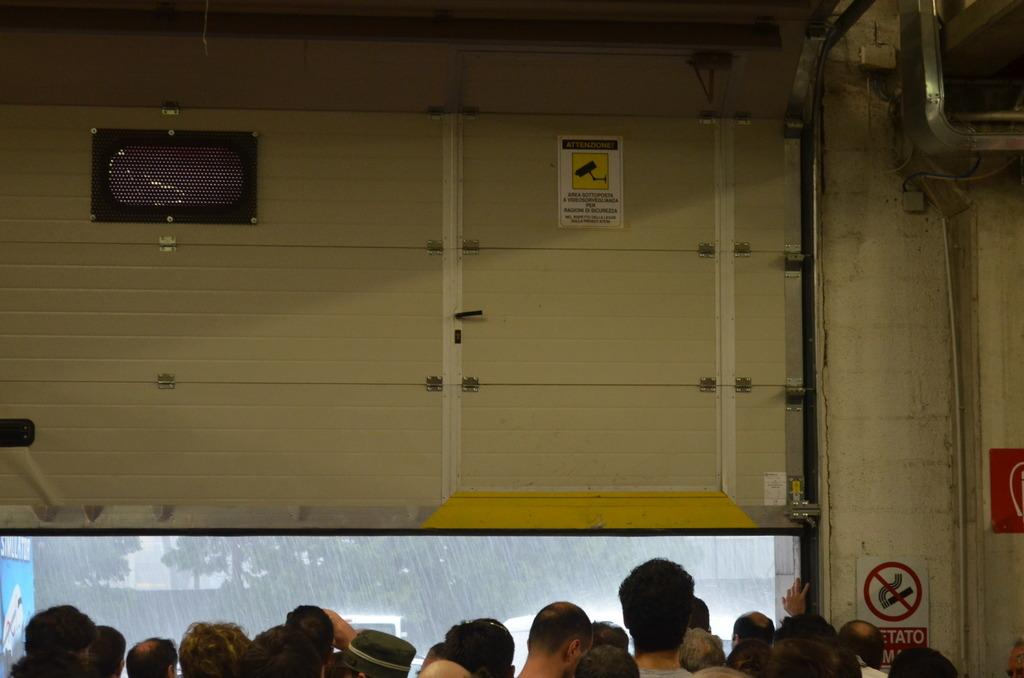How many people are in the image? There is a group of people in the image, but the exact number is not specified. Where are the people located? The people are inside a room. What can be seen in the image besides the people? There is a pipe and a poster in the image. What type of yoke is being used by the people in the image? There is no yoke present in the image. Can you see any cracks in the poster in the image? The condition of the poster, including any cracks, is not mentioned in the provided facts. 